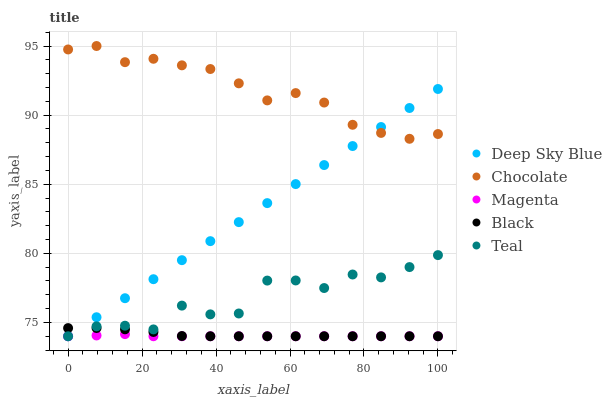Does Magenta have the minimum area under the curve?
Answer yes or no. Yes. Does Chocolate have the maximum area under the curve?
Answer yes or no. Yes. Does Black have the minimum area under the curve?
Answer yes or no. No. Does Black have the maximum area under the curve?
Answer yes or no. No. Is Deep Sky Blue the smoothest?
Answer yes or no. Yes. Is Teal the roughest?
Answer yes or no. Yes. Is Black the smoothest?
Answer yes or no. No. Is Black the roughest?
Answer yes or no. No. Does Magenta have the lowest value?
Answer yes or no. Yes. Does Chocolate have the lowest value?
Answer yes or no. No. Does Chocolate have the highest value?
Answer yes or no. Yes. Does Black have the highest value?
Answer yes or no. No. Is Magenta less than Chocolate?
Answer yes or no. Yes. Is Chocolate greater than Magenta?
Answer yes or no. Yes. Does Deep Sky Blue intersect Chocolate?
Answer yes or no. Yes. Is Deep Sky Blue less than Chocolate?
Answer yes or no. No. Is Deep Sky Blue greater than Chocolate?
Answer yes or no. No. Does Magenta intersect Chocolate?
Answer yes or no. No. 